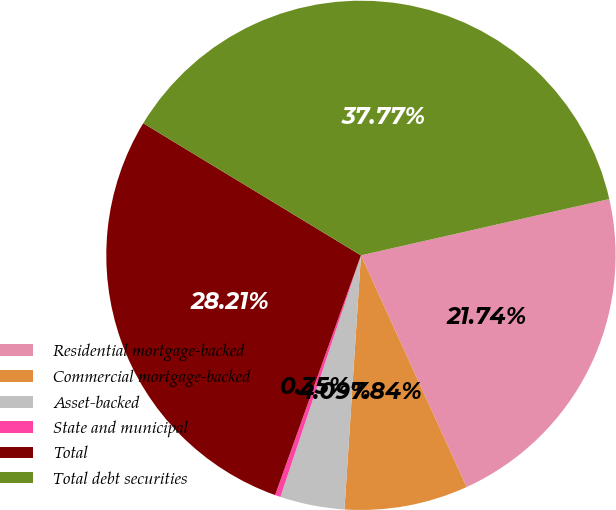Convert chart to OTSL. <chart><loc_0><loc_0><loc_500><loc_500><pie_chart><fcel>Residential mortgage-backed<fcel>Commercial mortgage-backed<fcel>Asset-backed<fcel>State and municipal<fcel>Total<fcel>Total debt securities<nl><fcel>21.74%<fcel>7.84%<fcel>4.09%<fcel>0.35%<fcel>28.21%<fcel>37.77%<nl></chart> 